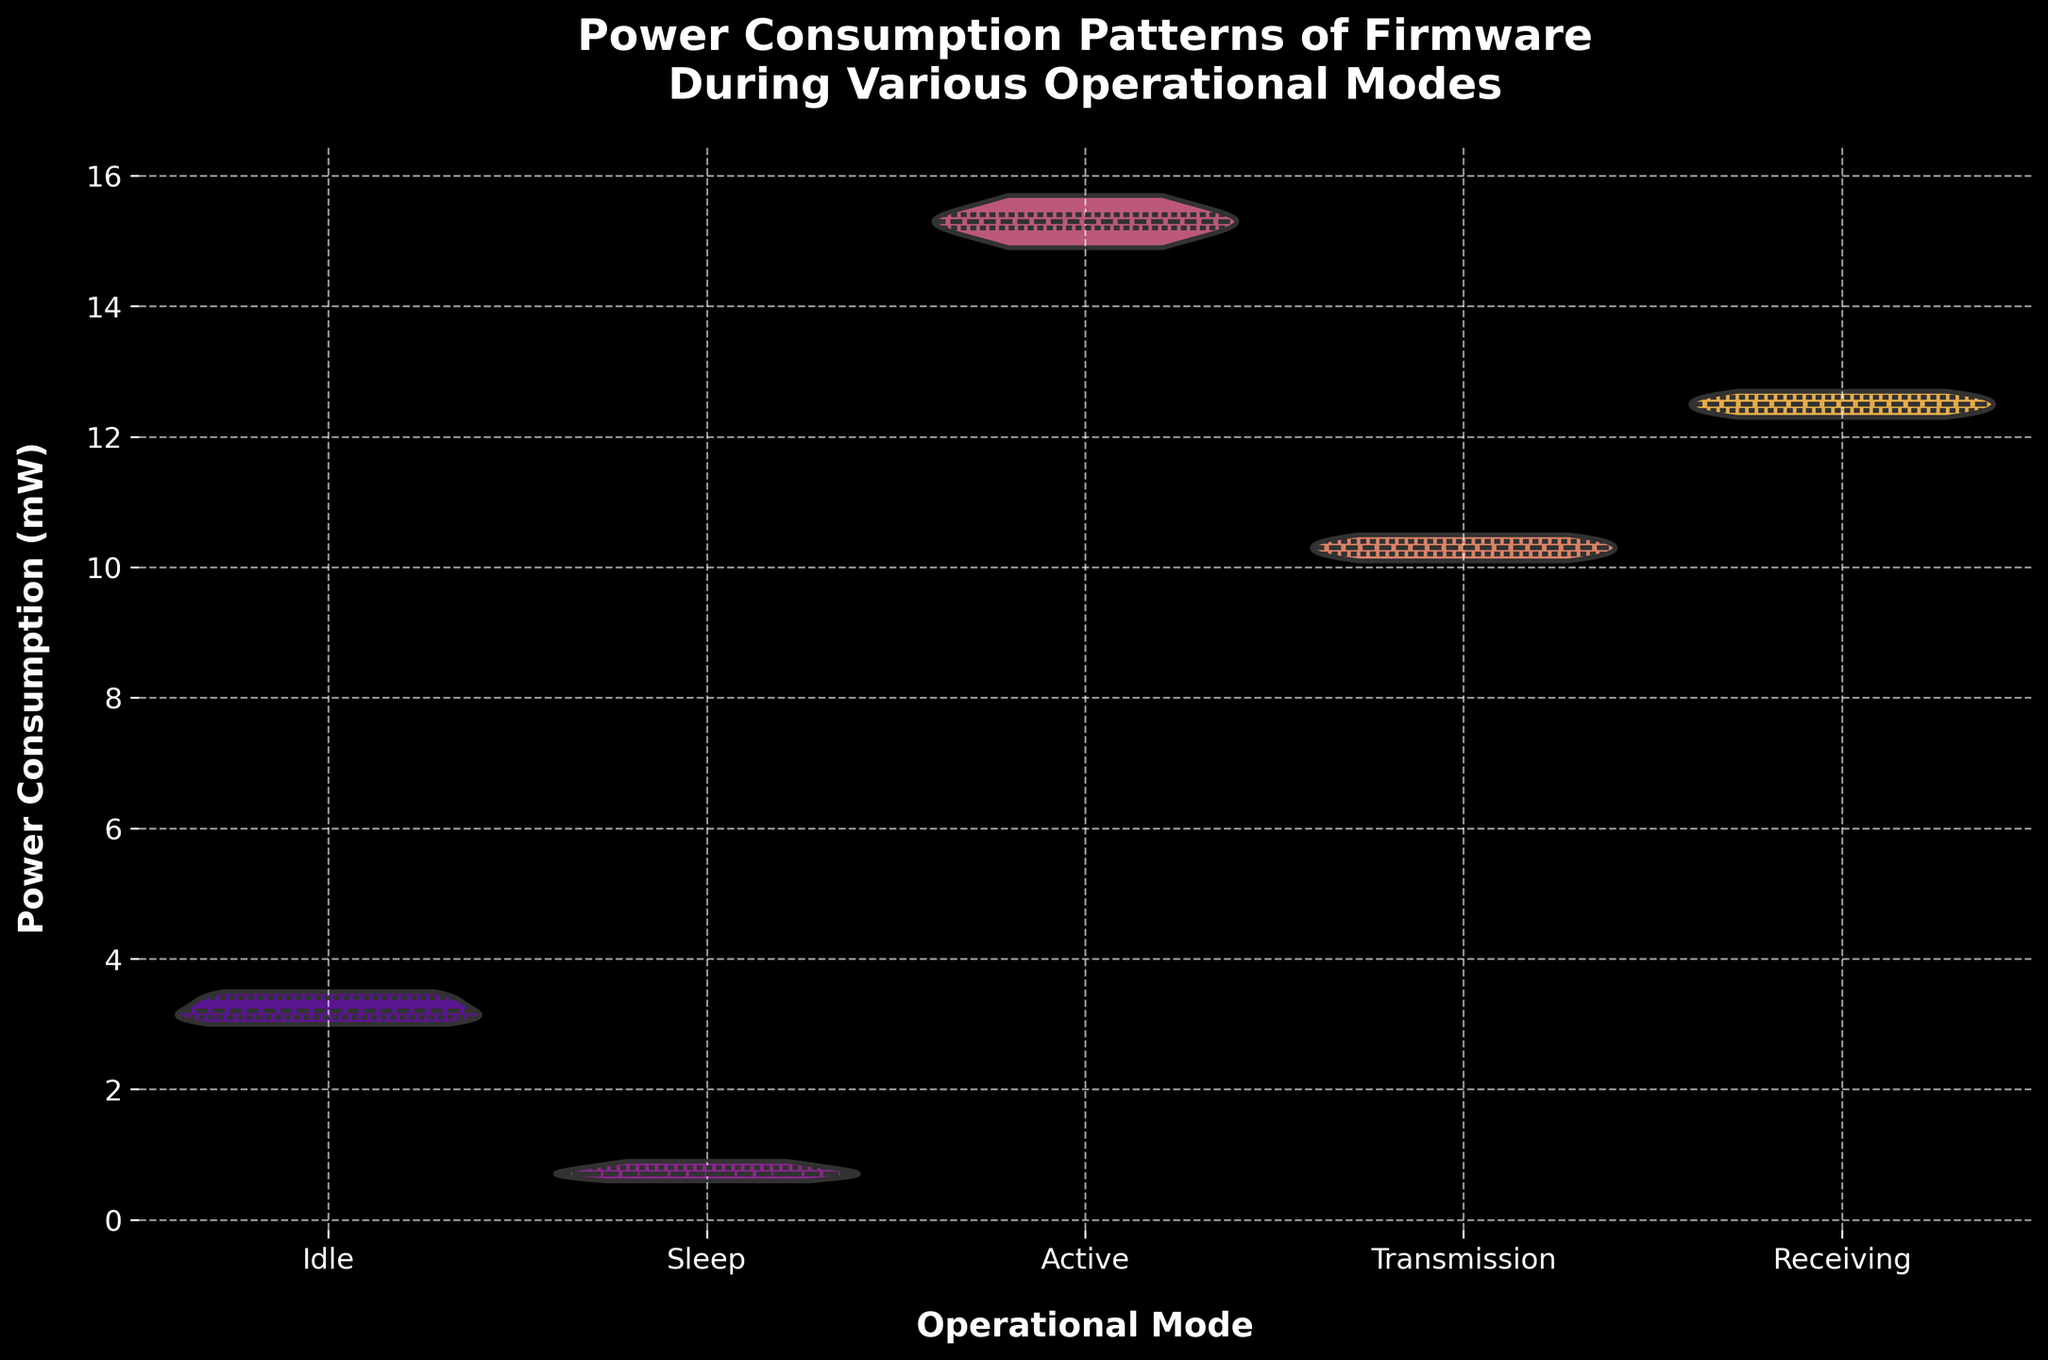What is the title of the figure? The title of the figure is displayed at the top of the plot in a larger font size and titled "Power Consumption Patterns of Firmware During Various Operational Modes."
Answer: Power Consumption Patterns of Firmware During Various Operational Modes Which operational mode has the highest average power consumption? By observing the centroids of the violins, the 'Active' mode has the highest average power consumption as its central part is positioned at a higher value than the other modes.
Answer: Active How many operational modes are displayed in the figure? The figure displays a violin plot for each operational mode, totaling five distinct categories along the x-axis: Idle, Sleep, Active, Transmission, and Receiving.
Answer: Five What is the range of power consumption values for the 'Idle' mode? The range is the maximum value minus the minimum value within the violin plot for the 'Idle' mode. 'Idle' mode ranges roughly from 3.0 to 3.5 mW.
Answer: 3.0 to 3.5 mW Which mode shows the smallest variability in power consumption? Variability is indicated by the width of the violin plot; the 'Sleep' mode shows the smallest variability since its violin is the narrowest among all modes.
Answer: Sleep What is the median power consumption for the 'Transmission' mode? The median is shown by the middle line inside the quartile segment of the 'Transmission' violin plot, roughly at 10.3 mW.
Answer: 10.3 mW In which operational mode is the power consumption more varied, 'Receiving' or 'Transmission'? Variation can be inferred from the spread of the distributions in the violin plots. 'Receiving' shows more spread compared to 'Transmission', indicating more variation.
Answer: Receiving What is the interquartile range (IQR) for power consumption in the 'Active' mode? The interquartile range is the distance between the first and third quartiles, visible within the violin plot for 'Active'. This range for the 'Active' mode is approximately from 15.0 to 15.5 mW.
Answer: 15.0 to 15.5 mW Which operational mode has the closest power consumption values? The mode with the smallest spread in its violin plot implies the closest power consumption values. This is the 'Sleep' mode, as the violin is very narrow.
Answer: Sleep 